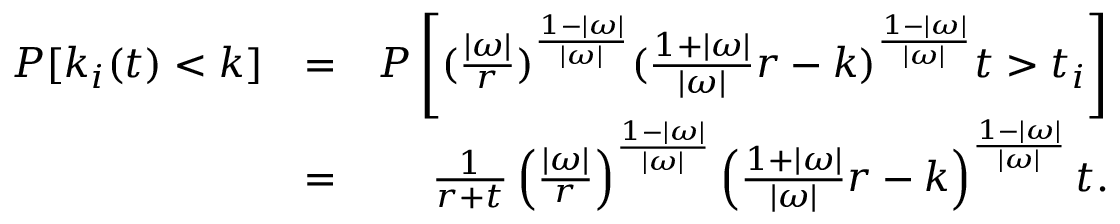Convert formula to latex. <formula><loc_0><loc_0><loc_500><loc_500>\begin{array} { r l r } { P [ k _ { i } ( t ) < k ] } & { = } & { P \left [ ( \frac { | \omega | } { r } ) ^ { \frac { 1 - | \omega | } { | \omega | } } ( \frac { 1 + | \omega | } { | \omega | } r - k ) ^ { \frac { 1 - | \omega | } { | \omega | } } t > t _ { i } \right ] } \\ & { = } & { \frac { 1 } { r + t } \left ( \frac { | \omega | } { r } \right ) ^ { \frac { 1 - | \omega | } { | \omega | } } \left ( \frac { 1 + | \omega | } { | \omega | } r - k \right ) ^ { \frac { 1 - | \omega | } { | \omega | } } t . } \end{array}</formula> 